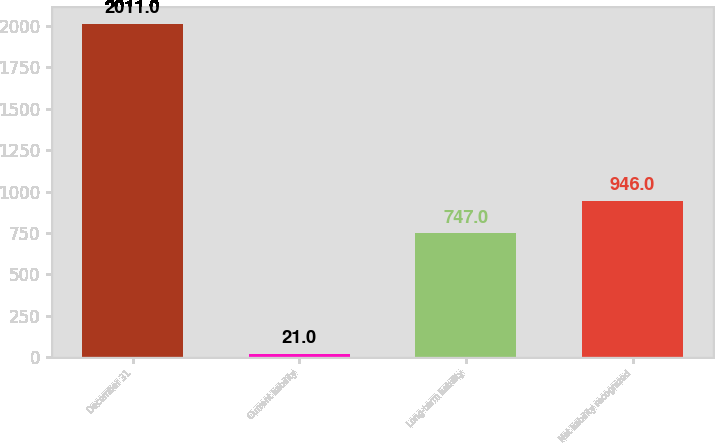Convert chart to OTSL. <chart><loc_0><loc_0><loc_500><loc_500><bar_chart><fcel>December 31<fcel>Current liability<fcel>Long-term liability<fcel>Net liability recognized<nl><fcel>2011<fcel>21<fcel>747<fcel>946<nl></chart> 